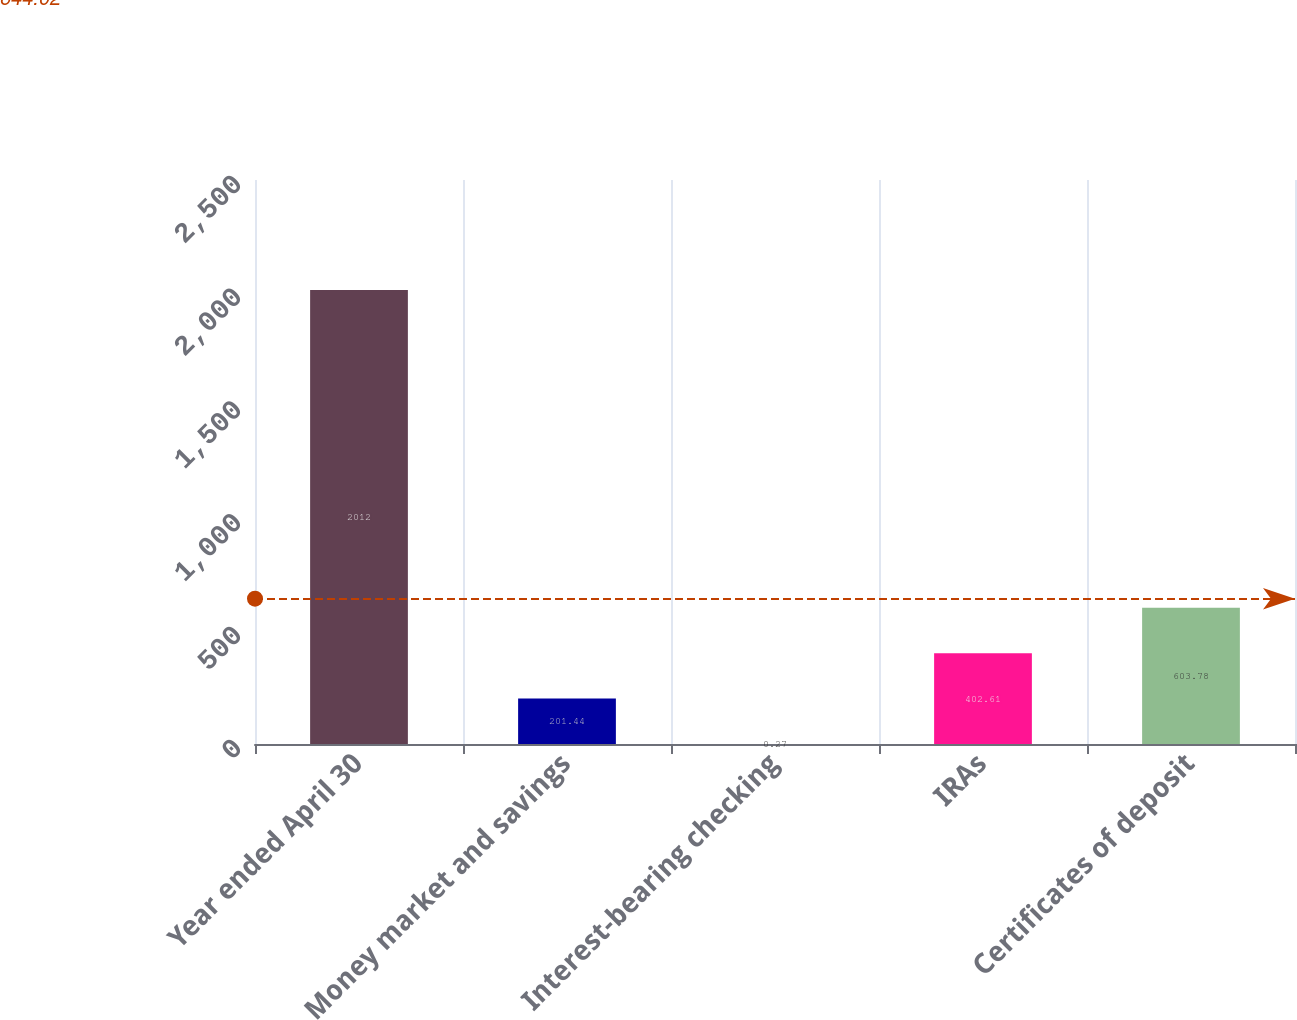Convert chart. <chart><loc_0><loc_0><loc_500><loc_500><bar_chart><fcel>Year ended April 30<fcel>Money market and savings<fcel>Interest-bearing checking<fcel>IRAs<fcel>Certificates of deposit<nl><fcel>2012<fcel>201.44<fcel>0.27<fcel>402.61<fcel>603.78<nl></chart> 